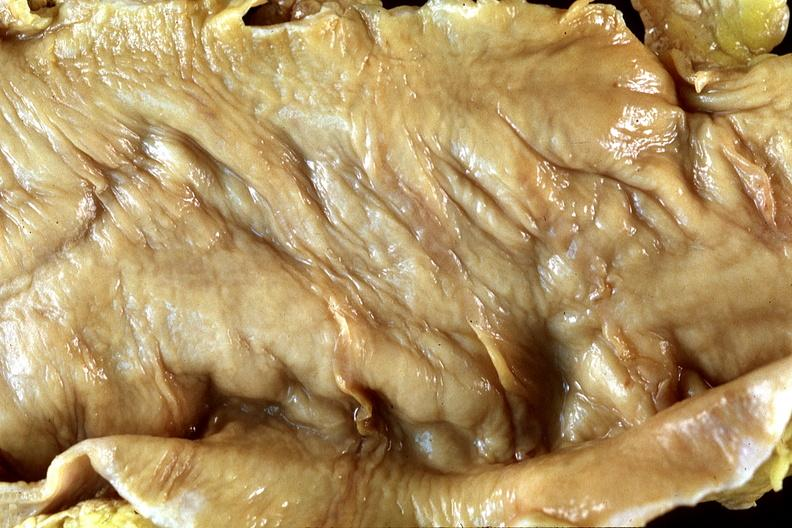s gastrointestinal present?
Answer the question using a single word or phrase. Yes 